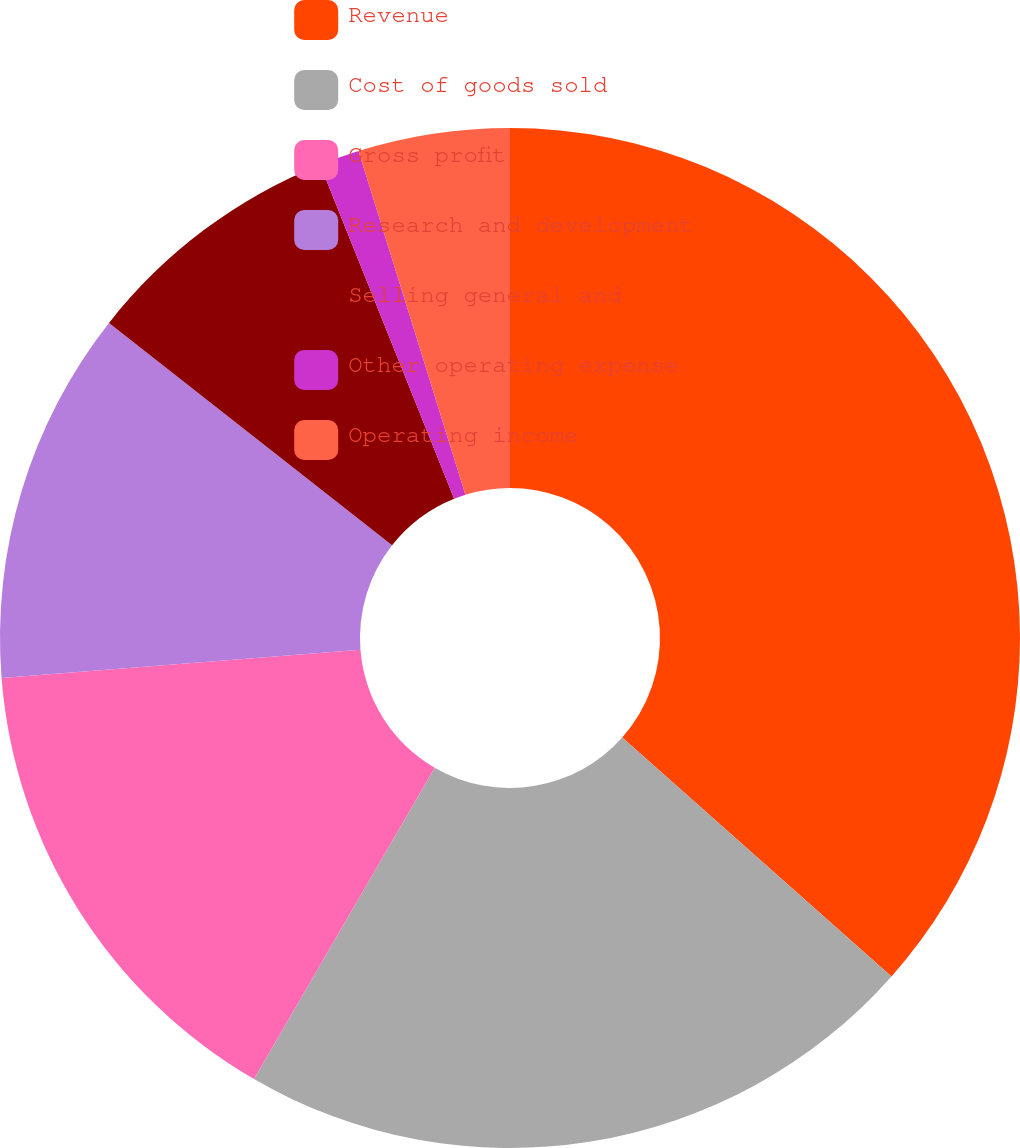Convert chart to OTSL. <chart><loc_0><loc_0><loc_500><loc_500><pie_chart><fcel>Revenue<fcel>Cost of goods sold<fcel>Gross profit<fcel>Research and development<fcel>Selling general and<fcel>Other operating expense<fcel>Operating income<nl><fcel>36.55%<fcel>21.82%<fcel>15.38%<fcel>11.85%<fcel>8.33%<fcel>1.27%<fcel>4.8%<nl></chart> 